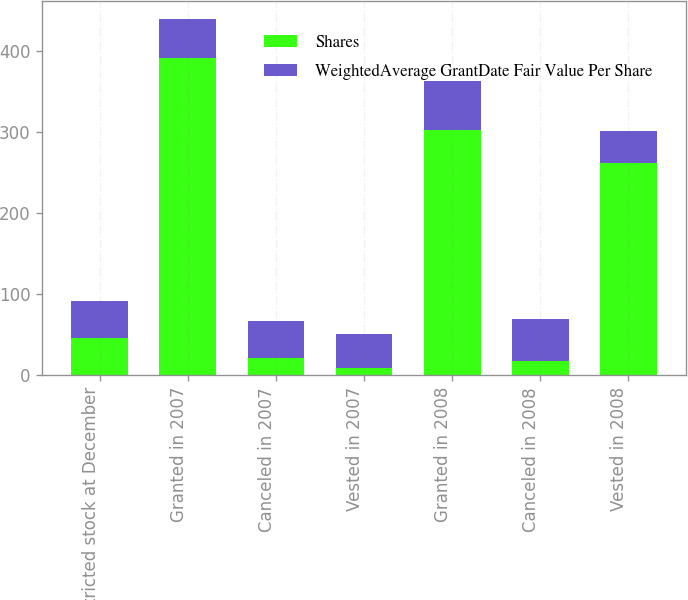Convert chart to OTSL. <chart><loc_0><loc_0><loc_500><loc_500><stacked_bar_chart><ecel><fcel>Restricted stock at December<fcel>Granted in 2007<fcel>Canceled in 2007<fcel>Vested in 2007<fcel>Granted in 2008<fcel>Canceled in 2008<fcel>Vested in 2008<nl><fcel>Shares<fcel>45.88<fcel>391<fcel>21<fcel>9<fcel>302<fcel>17<fcel>262<nl><fcel>WeightedAverage GrantDate Fair Value Per Share<fcel>45.65<fcel>48.43<fcel>45.88<fcel>42.06<fcel>61<fcel>52.86<fcel>39.95<nl></chart> 